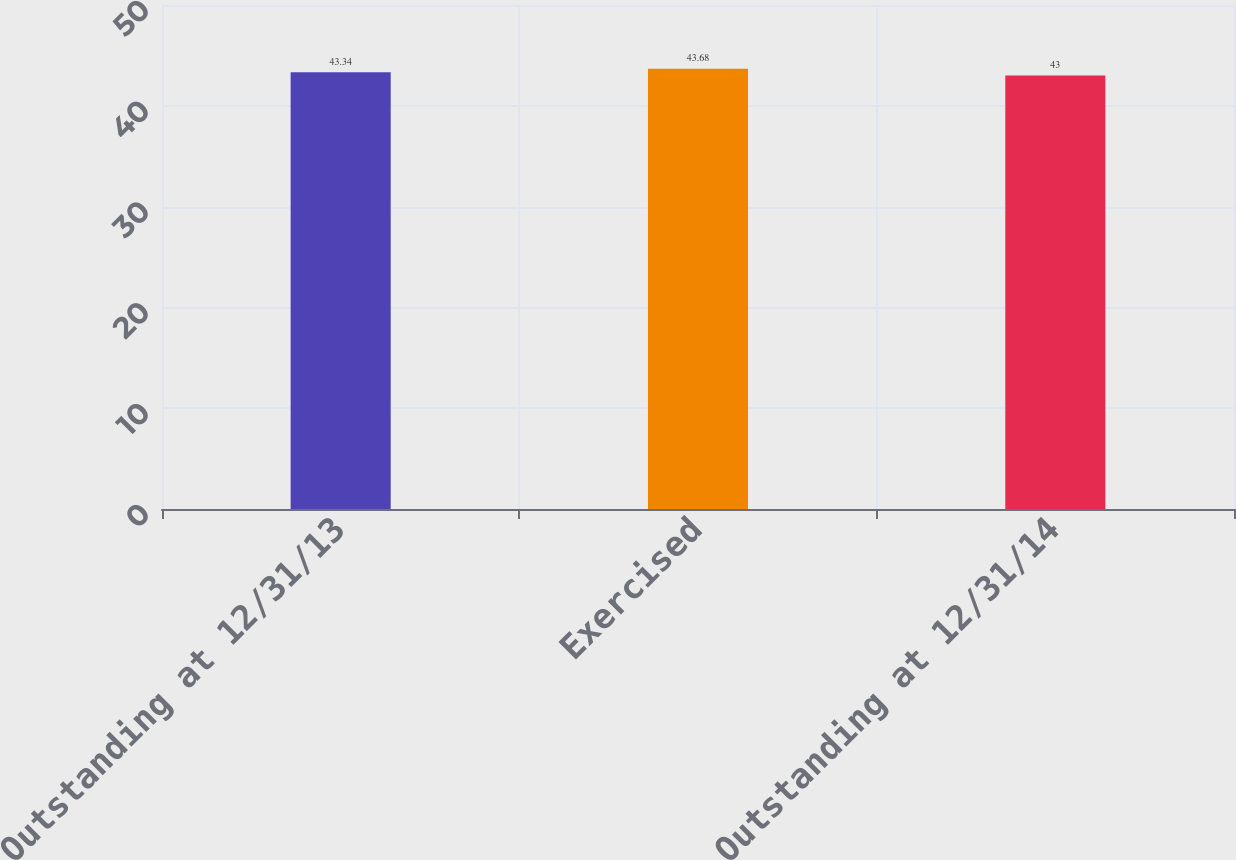Convert chart. <chart><loc_0><loc_0><loc_500><loc_500><bar_chart><fcel>Outstanding at 12/31/13<fcel>Exercised<fcel>Outstanding at 12/31/14<nl><fcel>43.34<fcel>43.68<fcel>43<nl></chart> 